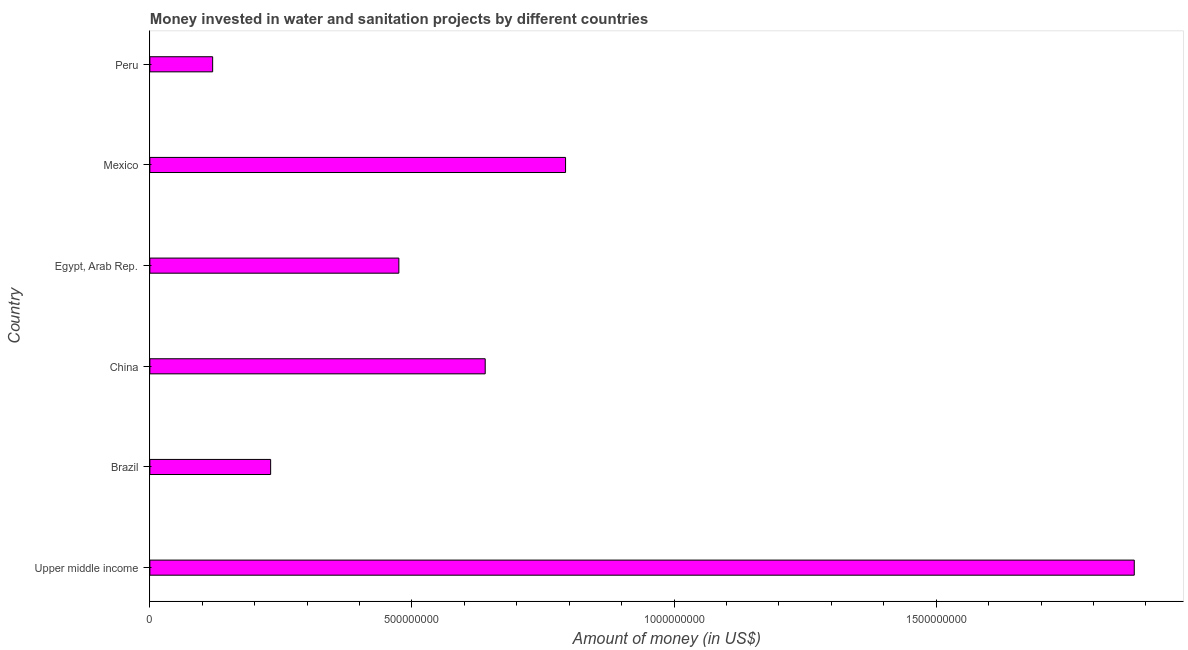Does the graph contain grids?
Your response must be concise. No. What is the title of the graph?
Your answer should be very brief. Money invested in water and sanitation projects by different countries. What is the label or title of the X-axis?
Give a very brief answer. Amount of money (in US$). What is the investment in Brazil?
Your answer should be very brief. 2.30e+08. Across all countries, what is the maximum investment?
Ensure brevity in your answer.  1.88e+09. Across all countries, what is the minimum investment?
Your answer should be compact. 1.20e+08. In which country was the investment maximum?
Provide a succinct answer. Upper middle income. What is the sum of the investment?
Offer a terse response. 4.14e+09. What is the difference between the investment in China and Mexico?
Provide a short and direct response. -1.53e+08. What is the average investment per country?
Your response must be concise. 6.89e+08. What is the median investment?
Keep it short and to the point. 5.57e+08. In how many countries, is the investment greater than 1400000000 US$?
Give a very brief answer. 1. What is the ratio of the investment in China to that in Peru?
Keep it short and to the point. 5.34. What is the difference between the highest and the second highest investment?
Provide a succinct answer. 1.08e+09. Is the sum of the investment in China and Mexico greater than the maximum investment across all countries?
Give a very brief answer. No. What is the difference between the highest and the lowest investment?
Make the answer very short. 1.76e+09. In how many countries, is the investment greater than the average investment taken over all countries?
Give a very brief answer. 2. How many bars are there?
Keep it short and to the point. 6. Are the values on the major ticks of X-axis written in scientific E-notation?
Provide a succinct answer. No. What is the Amount of money (in US$) of Upper middle income?
Keep it short and to the point. 1.88e+09. What is the Amount of money (in US$) of Brazil?
Provide a short and direct response. 2.30e+08. What is the Amount of money (in US$) of China?
Keep it short and to the point. 6.40e+08. What is the Amount of money (in US$) in Egypt, Arab Rep.?
Your response must be concise. 4.75e+08. What is the Amount of money (in US$) of Mexico?
Provide a succinct answer. 7.93e+08. What is the Amount of money (in US$) of Peru?
Provide a short and direct response. 1.20e+08. What is the difference between the Amount of money (in US$) in Upper middle income and Brazil?
Your response must be concise. 1.65e+09. What is the difference between the Amount of money (in US$) in Upper middle income and China?
Provide a short and direct response. 1.24e+09. What is the difference between the Amount of money (in US$) in Upper middle income and Egypt, Arab Rep.?
Your response must be concise. 1.40e+09. What is the difference between the Amount of money (in US$) in Upper middle income and Mexico?
Your answer should be compact. 1.08e+09. What is the difference between the Amount of money (in US$) in Upper middle income and Peru?
Offer a very short reply. 1.76e+09. What is the difference between the Amount of money (in US$) in Brazil and China?
Your response must be concise. -4.09e+08. What is the difference between the Amount of money (in US$) in Brazil and Egypt, Arab Rep.?
Give a very brief answer. -2.45e+08. What is the difference between the Amount of money (in US$) in Brazil and Mexico?
Offer a terse response. -5.63e+08. What is the difference between the Amount of money (in US$) in Brazil and Peru?
Your answer should be very brief. 1.11e+08. What is the difference between the Amount of money (in US$) in China and Egypt, Arab Rep.?
Keep it short and to the point. 1.65e+08. What is the difference between the Amount of money (in US$) in China and Mexico?
Ensure brevity in your answer.  -1.53e+08. What is the difference between the Amount of money (in US$) in China and Peru?
Give a very brief answer. 5.20e+08. What is the difference between the Amount of money (in US$) in Egypt, Arab Rep. and Mexico?
Offer a terse response. -3.18e+08. What is the difference between the Amount of money (in US$) in Egypt, Arab Rep. and Peru?
Your response must be concise. 3.55e+08. What is the difference between the Amount of money (in US$) in Mexico and Peru?
Your answer should be very brief. 6.73e+08. What is the ratio of the Amount of money (in US$) in Upper middle income to that in Brazil?
Offer a terse response. 8.15. What is the ratio of the Amount of money (in US$) in Upper middle income to that in China?
Provide a short and direct response. 2.94. What is the ratio of the Amount of money (in US$) in Upper middle income to that in Egypt, Arab Rep.?
Give a very brief answer. 3.95. What is the ratio of the Amount of money (in US$) in Upper middle income to that in Mexico?
Offer a very short reply. 2.37. What is the ratio of the Amount of money (in US$) in Upper middle income to that in Peru?
Ensure brevity in your answer.  15.68. What is the ratio of the Amount of money (in US$) in Brazil to that in China?
Provide a short and direct response. 0.36. What is the ratio of the Amount of money (in US$) in Brazil to that in Egypt, Arab Rep.?
Give a very brief answer. 0.48. What is the ratio of the Amount of money (in US$) in Brazil to that in Mexico?
Your answer should be very brief. 0.29. What is the ratio of the Amount of money (in US$) in Brazil to that in Peru?
Provide a succinct answer. 1.92. What is the ratio of the Amount of money (in US$) in China to that in Egypt, Arab Rep.?
Make the answer very short. 1.35. What is the ratio of the Amount of money (in US$) in China to that in Mexico?
Your answer should be compact. 0.81. What is the ratio of the Amount of money (in US$) in China to that in Peru?
Give a very brief answer. 5.34. What is the ratio of the Amount of money (in US$) in Egypt, Arab Rep. to that in Mexico?
Offer a very short reply. 0.6. What is the ratio of the Amount of money (in US$) in Egypt, Arab Rep. to that in Peru?
Offer a terse response. 3.96. What is the ratio of the Amount of money (in US$) in Mexico to that in Peru?
Your response must be concise. 6.62. 